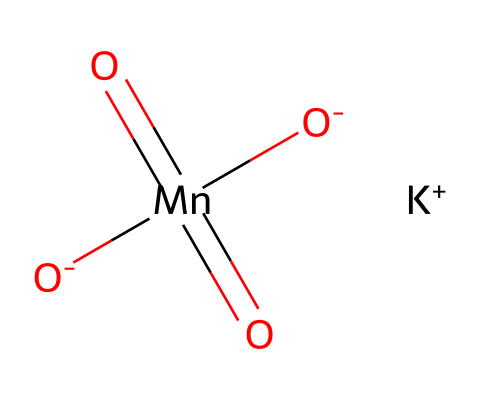What is the molecular formula of potassium permanganate? The SMILES representation can be broken down to identify the constituent atoms: 1 potassium (K), 1 manganese (Mn), and 4 oxygen (O) atoms. Therefore, the molecular formula can be deduced as KMnO4.
Answer: KMnO4 How many oxygen atoms are present in potassium permanganate? The SMILES representation indicates four oxygen atoms, as denoted by the "O" symbols in the formula.
Answer: 4 What oxidation state does manganese (Mn) have in potassium permanganate? In this structure, manganese is typically in the +7 oxidation state, inferred from its bonding with four oxygen atoms, each of which typically has a -2 charge in this context.
Answer: +7 How does the presence of potassium affect the solubility of potassium permanganate? The potassium ion (K+) in the structure provides a cationic component that enhances the ionic interaction with water, significantly increasing solubility.
Answer: increases solubility What type of reaction is potassium permanganate typically involved in due to its oxidizing properties? Potassium permanganate is commonly used in redox reactions as an oxidizing agent, where it gains electrons and thus facilitates the oxidation of other substances.
Answer: redox reactions 